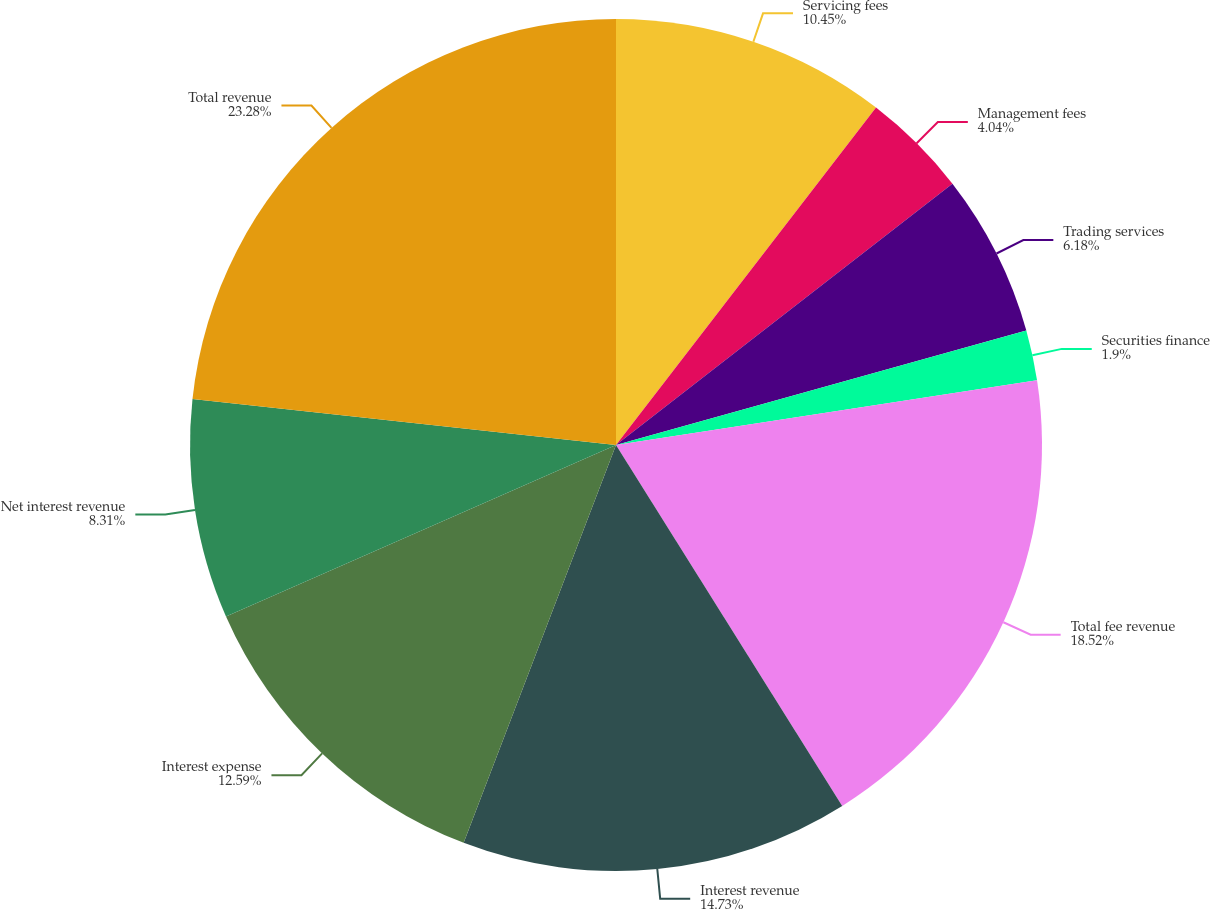Convert chart. <chart><loc_0><loc_0><loc_500><loc_500><pie_chart><fcel>Servicing fees<fcel>Management fees<fcel>Trading services<fcel>Securities finance<fcel>Total fee revenue<fcel>Interest revenue<fcel>Interest expense<fcel>Net interest revenue<fcel>Total revenue<nl><fcel>10.45%<fcel>4.04%<fcel>6.18%<fcel>1.9%<fcel>18.52%<fcel>14.73%<fcel>12.59%<fcel>8.31%<fcel>23.28%<nl></chart> 